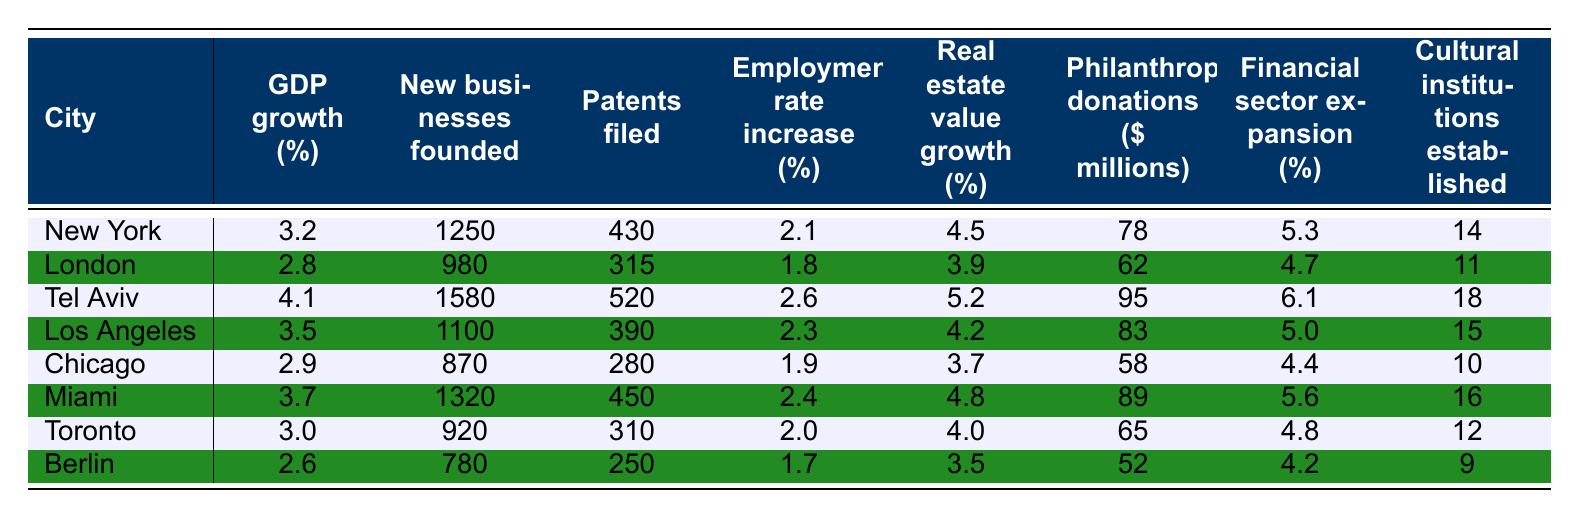What's the GDP growth percentage for Tel Aviv? The table shows that the GDP growth percentage for Tel Aviv is listed under that city, which is 4.1%.
Answer: 4.1% Which city has the highest number of new businesses founded? The table indicates that Tel Aviv has the highest number of new businesses founded, which is 1580.
Answer: 1580 Is the employment rate increase in Berlin higher than that in London? By comparing the employment rate increase values, Berlin has 1.7% while London has 1.8%, which shows that London's rate is higher.
Answer: No What is the total number of patents filed in New York and Miami combined? The patents filed for New York are 430 and for Miami are 450. Adding these values gives 430 + 450 = 880.
Answer: 880 What is the average philanthropic donation across all cities? To find the average, sum all the philanthropic donations: 78 + 62 + 95 + 83 + 58 + 89 + 65 + 52 = 522. Divide by 8 (the number of cities), giving 522 / 8 = 65.25.
Answer: 65.25 In which city is the financial sector contraction the highest? By assessing the financial sector expansion percentages, Tel Aviv shows the highest rate at 6.1%.
Answer: Tel Aviv How does the real estate value growth in Los Angeles compare to that in Toronto? The real estate value growth in Los Angeles is 4.2% while in Toronto it is 4.0%. Thus, Los Angeles has a slightly higher growth.
Answer: Los Angeles Which city has the lowest cultural institutions established? Comparing the number of cultural institutions established, Berlin has the lowest at 9.
Answer: Berlin What’s the difference in GDP growth percentage between Chicago and New York? Chicago has a GDP growth of 2.9% and New York has 3.2%. The difference is 3.2 - 2.9 = 0.3%.
Answer: 0.3% Which two cities have a philanthropic donation of over $80 million? By evaluating the donations, Tel Aviv (95) and Miami (89) exceed $80 million.
Answer: Tel Aviv and Miami 